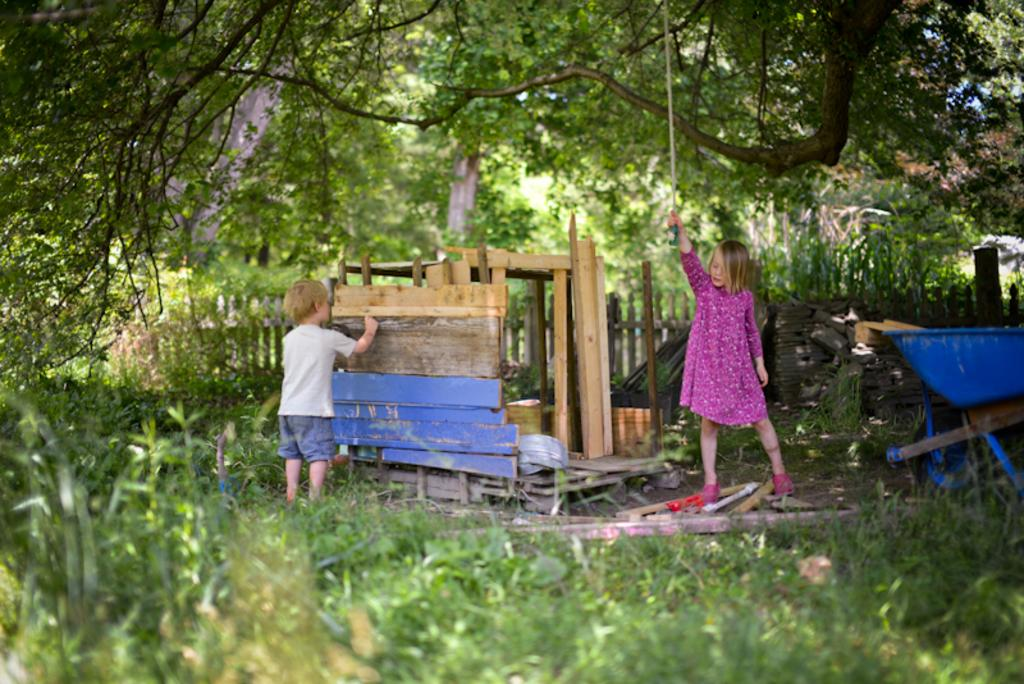What type of living organisms can be seen in the image? Plants are visible in the image. What object can be used for transportation in the image? There is a cart in the image that can be used for transportation. Who is present in the image? There is a boy in the image. What material is used for some objects in the image? There are wooden objects in the image. What structure can be seen in the image? There is a fence in the image. What is the girl holding in the image? The girl is holding an object in the image. What can be seen in the background of the image? Trees are visible in the background of the image. Can you tell me how many pigs are visible in the image? There are no pigs present in the image. What type of book is the girl reading in the image? There is no book present in the image, and the girl is not reading. 